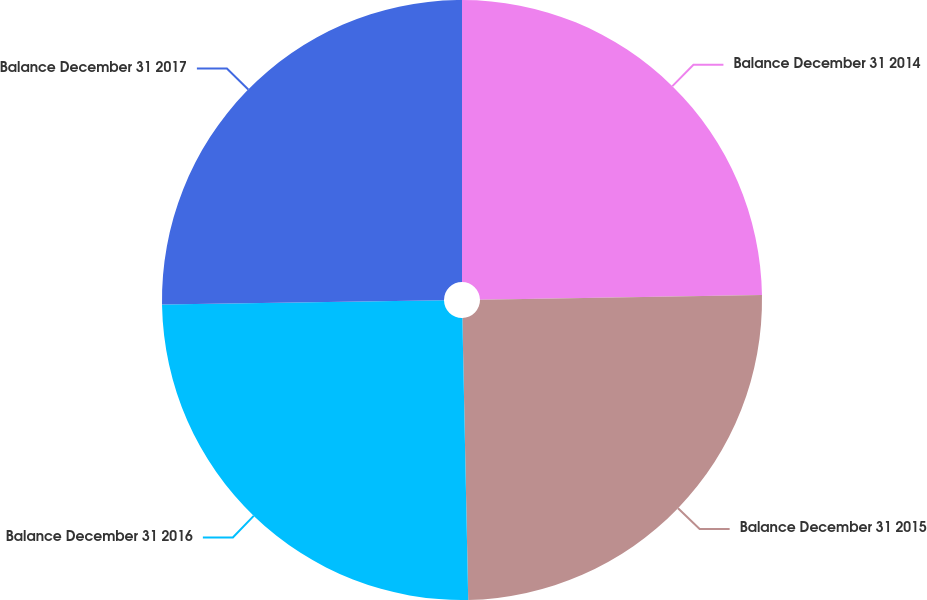Convert chart. <chart><loc_0><loc_0><loc_500><loc_500><pie_chart><fcel>Balance December 31 2014<fcel>Balance December 31 2015<fcel>Balance December 31 2016<fcel>Balance December 31 2017<nl><fcel>24.74%<fcel>24.93%<fcel>25.09%<fcel>25.24%<nl></chart> 